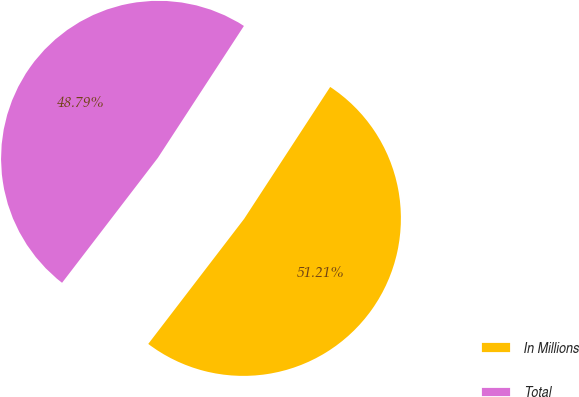Convert chart. <chart><loc_0><loc_0><loc_500><loc_500><pie_chart><fcel>In Millions<fcel>Total<nl><fcel>51.21%<fcel>48.79%<nl></chart> 